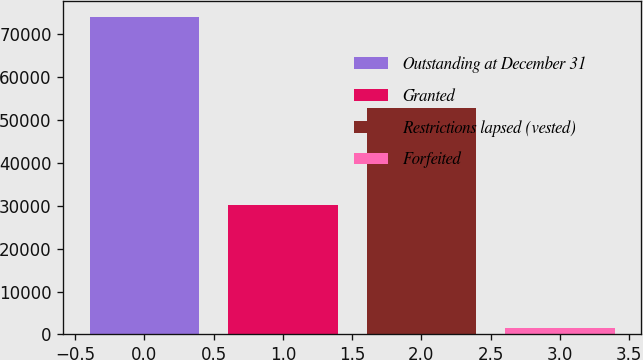Convert chart. <chart><loc_0><loc_0><loc_500><loc_500><bar_chart><fcel>Outstanding at December 31<fcel>Granted<fcel>Restrictions lapsed (vested)<fcel>Forfeited<nl><fcel>74003<fcel>30074<fcel>52785<fcel>1570<nl></chart> 